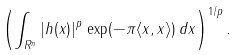<formula> <loc_0><loc_0><loc_500><loc_500>\left ( \int _ { { R } ^ { n } } | h ( x ) | ^ { p } \, \exp ( - \pi \langle x , x \rangle ) \, d x \right ) ^ { 1 / p } .</formula> 